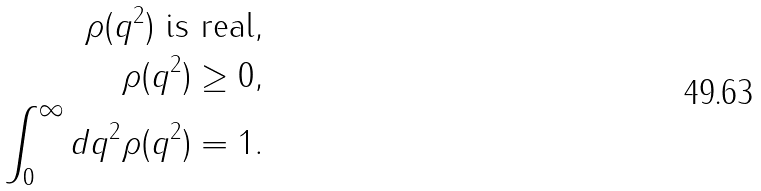Convert formula to latex. <formula><loc_0><loc_0><loc_500><loc_500>\rho ( q ^ { 2 } ) \text { is real} & , \\ \rho ( q ^ { 2 } ) \geq 0 & , \\ \int _ { 0 } ^ { \infty } d q ^ { 2 } \rho ( q ^ { 2 } ) = 1 & .</formula> 